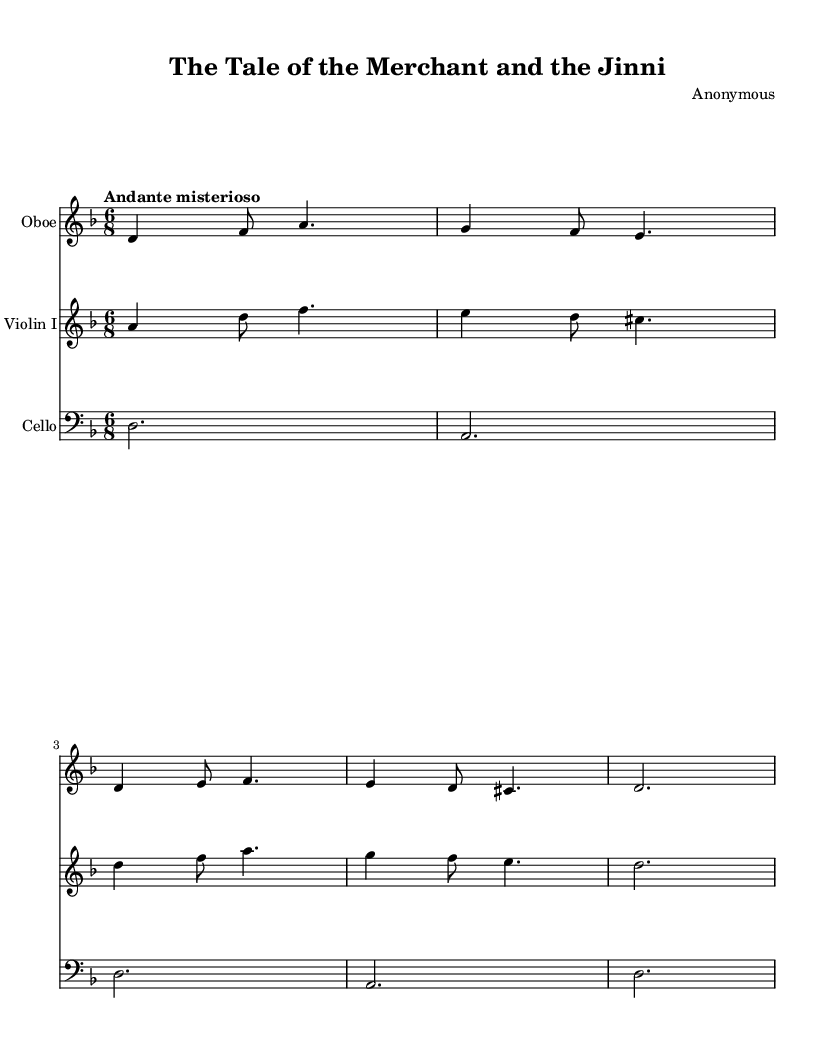What is the key signature of this music? The key signature displayed in the sheet music is D minor. This can be determined by identifying the 'D' indicated at the beginning of the score and counting one flat in the key signature, which corresponds to B flat.
Answer: D minor What is the time signature of this music? The time signature shown at the beginning of the score is 6/8. This is represented by the notation '6/8' directly following the clef and key signature at the start of the piece.
Answer: 6/8 What is the tempo marking given in the music? The tempo marking indicated in the score is "Andante misterioso." This is explicitly stated in the tempo indication line that specifies the character and speed at which the music should be played.
Answer: Andante misterioso Which instrument plays the melody in the first measure? The oboe plays the melody in the first measure, as seen in the top staff where the oboe part is notated distinctly from the other instruments.
Answer: Oboe How many measures are present in the oboe part? The oboe part consists of five measures, which can be counted by examining the horizontal bar lines that separate each measure in the notation.
Answer: 5 Compare the rhythmic pattern of the violin part to that of the cello part. What stands out? The violin part has a mix of quarter notes and eighth notes, creating a more complex rhythmic pattern while the cello part consists solely of whole notes, leading to a simpler rhythm. This contrast indicates different roles within the ensemble.
Answer: Complex and simple 